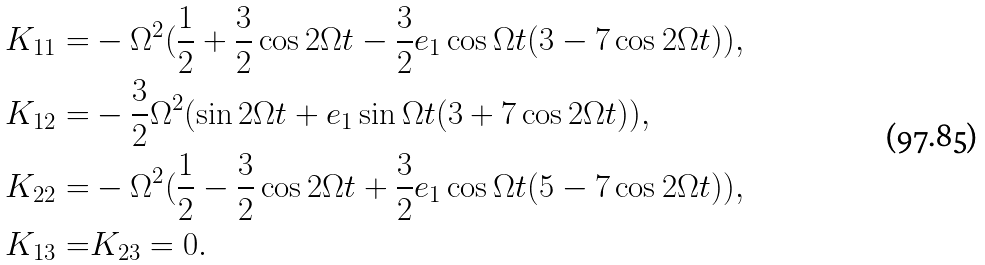<formula> <loc_0><loc_0><loc_500><loc_500>K _ { 1 1 } = & - \Omega ^ { 2 } ( \frac { 1 } { 2 } + \frac { 3 } { 2 } \cos { 2 \Omega t } - \frac { 3 } { 2 } e _ { 1 } \cos { \Omega t } ( 3 - 7 \cos { 2 \Omega t } ) ) , \\ K _ { 1 2 } = & - \frac { 3 } { 2 } \Omega ^ { 2 } ( \sin { 2 \Omega t } + e _ { 1 } \sin { \Omega t } ( 3 + 7 \cos { 2 \Omega t } ) ) , \\ K _ { 2 2 } = & - \Omega ^ { 2 } ( \frac { 1 } { 2 } - \frac { 3 } { 2 } \cos { 2 \Omega t } + \frac { 3 } { 2 } e _ { 1 } \cos { \Omega t } ( 5 - 7 \cos { 2 \Omega t } ) ) , \\ K _ { 1 3 } = & K _ { 2 3 } = 0 .</formula> 